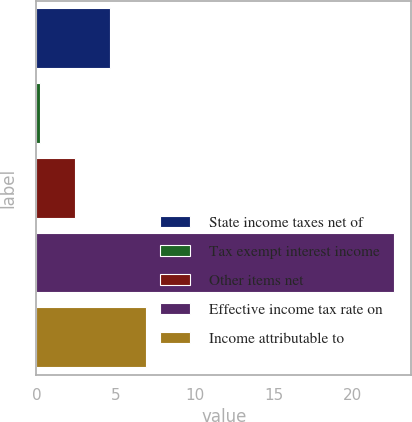Convert chart. <chart><loc_0><loc_0><loc_500><loc_500><bar_chart><fcel>State income taxes net of<fcel>Tax exempt interest income<fcel>Other items net<fcel>Effective income tax rate on<fcel>Income attributable to<nl><fcel>4.68<fcel>0.2<fcel>2.44<fcel>22.6<fcel>6.92<nl></chart> 